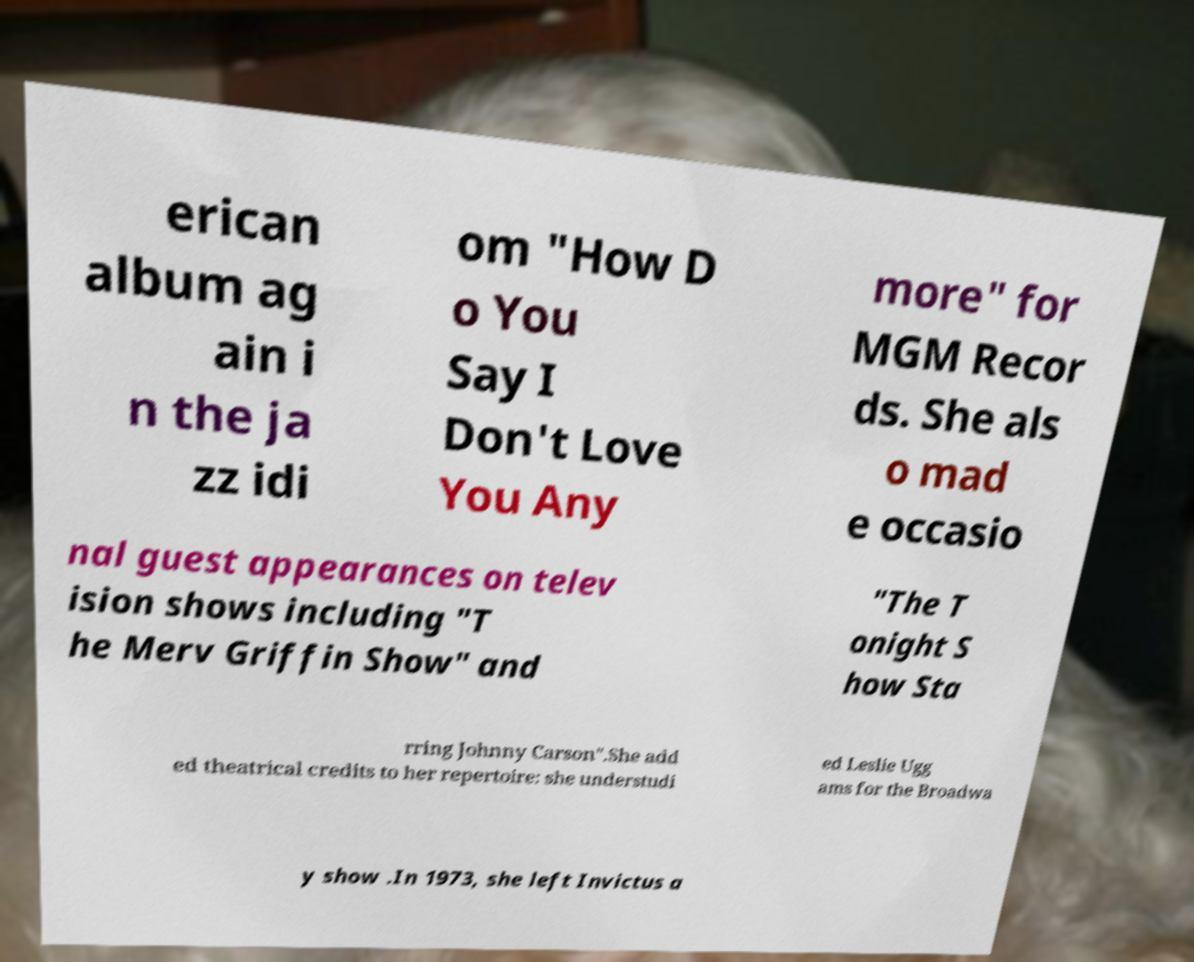I need the written content from this picture converted into text. Can you do that? erican album ag ain i n the ja zz idi om "How D o You Say I Don't Love You Any more" for MGM Recor ds. She als o mad e occasio nal guest appearances on telev ision shows including "T he Merv Griffin Show" and "The T onight S how Sta rring Johnny Carson".She add ed theatrical credits to her repertoire: she understudi ed Leslie Ugg ams for the Broadwa y show .In 1973, she left Invictus a 